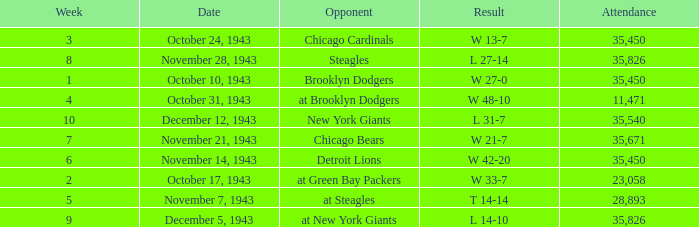What is the lowest attendance that has a week less than 4, and w 13-7 as the result? 35450.0. 